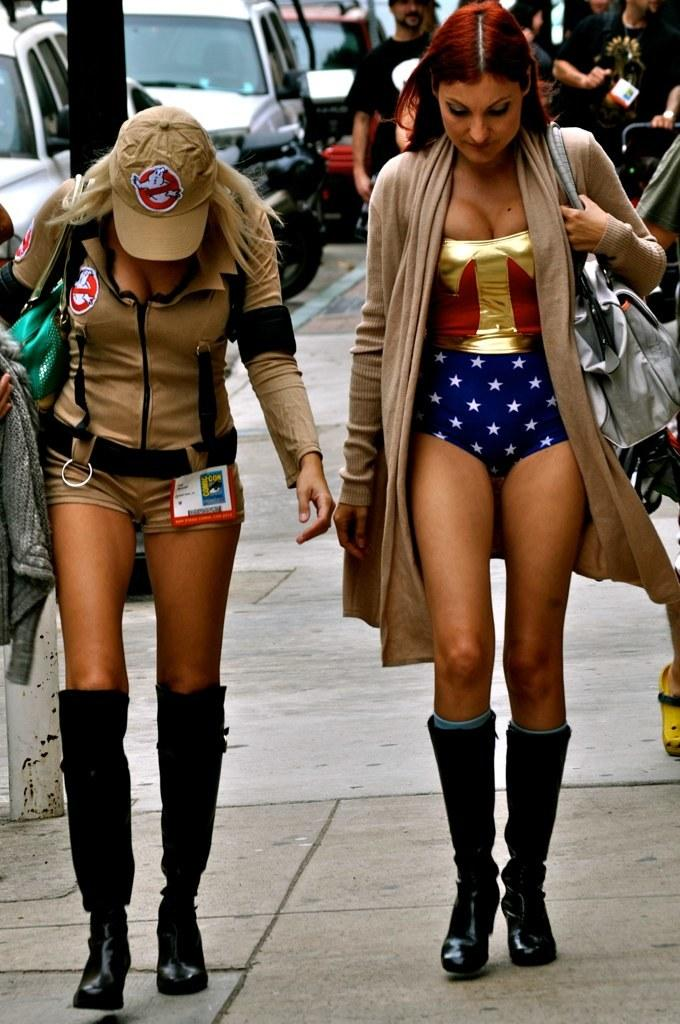How many ladies are in the image? There are two ladies in the image. What are the ladies doing in the image? The ladies are walking. What are the ladies carrying with them? The ladies are wearing handbags. What can be seen in the background of the image? There are people and cars in the background of the image. What type of grip strength test can be seen being performed in the image? There is no grip strength test present in the image; it features two ladies walking. 